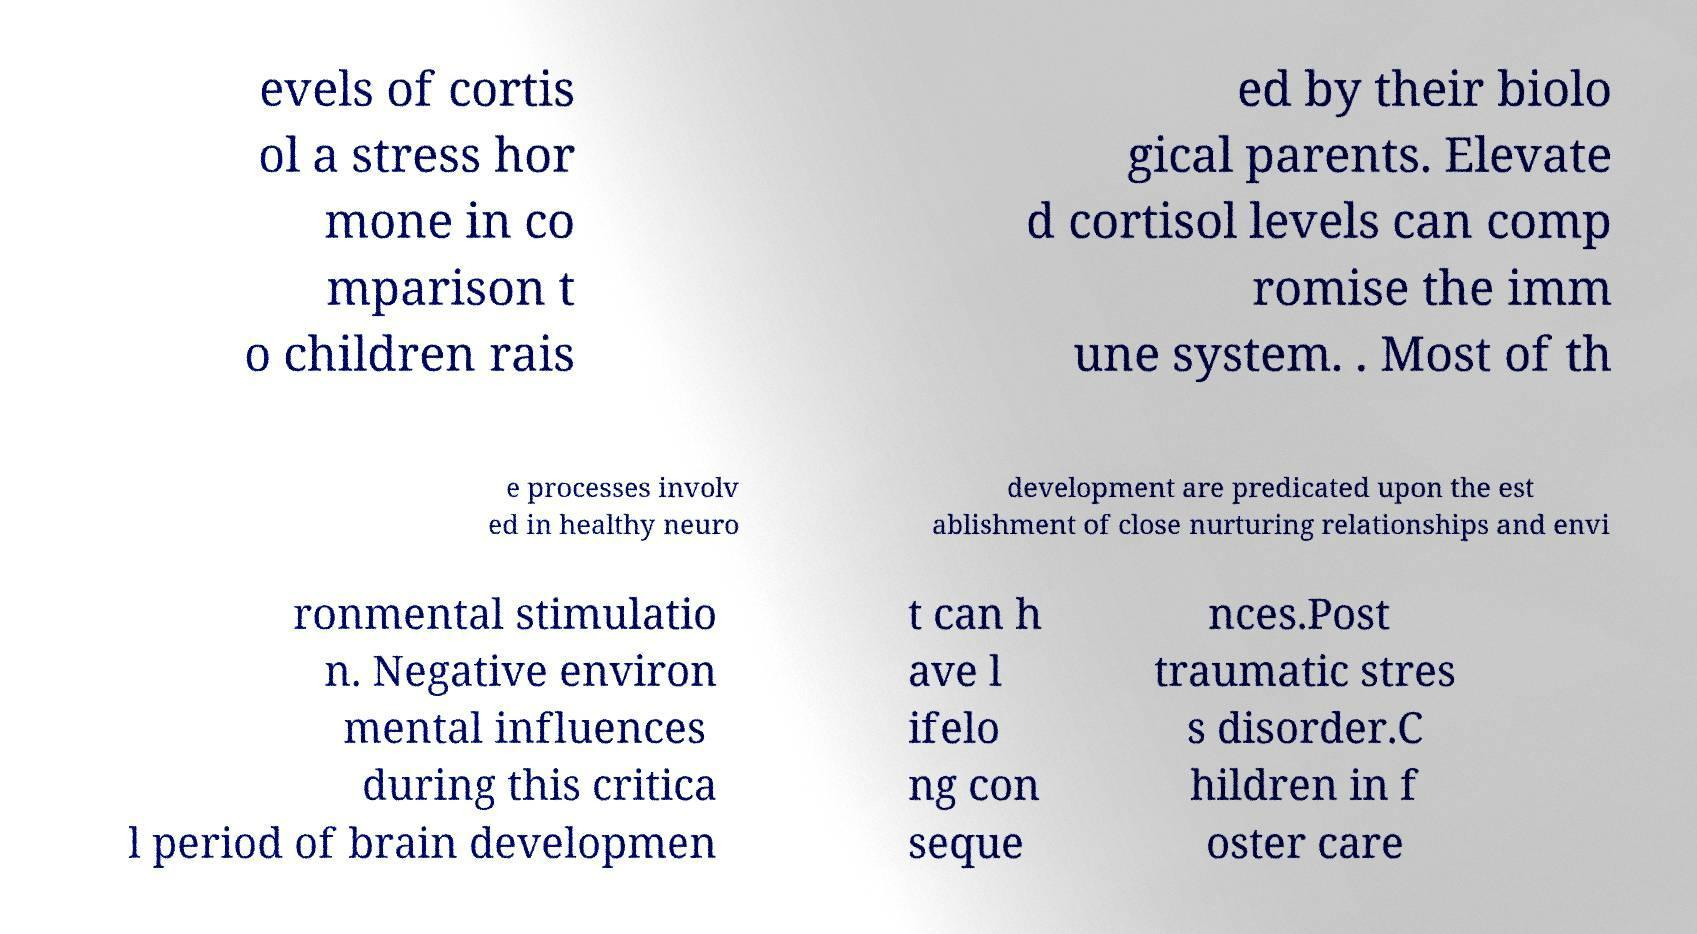Please read and relay the text visible in this image. What does it say? evels of cortis ol a stress hor mone in co mparison t o children rais ed by their biolo gical parents. Elevate d cortisol levels can comp romise the imm une system. . Most of th e processes involv ed in healthy neuro development are predicated upon the est ablishment of close nurturing relationships and envi ronmental stimulatio n. Negative environ mental influences during this critica l period of brain developmen t can h ave l ifelo ng con seque nces.Post traumatic stres s disorder.C hildren in f oster care 